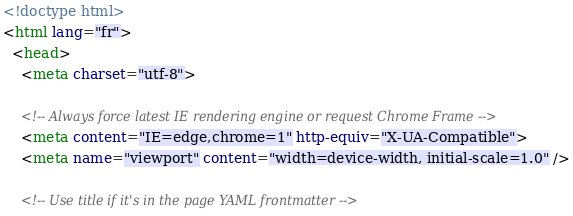Convert code to text. <code><loc_0><loc_0><loc_500><loc_500><_HTML_><!doctype html>
<html lang="fr">
  <head>
    <meta charset="utf-8">

    <!-- Always force latest IE rendering engine or request Chrome Frame -->
    <meta content="IE=edge,chrome=1" http-equiv="X-UA-Compatible">
    <meta name="viewport" content="width=device-width, initial-scale=1.0" />

    <!-- Use title if it's in the page YAML frontmatter --></code> 